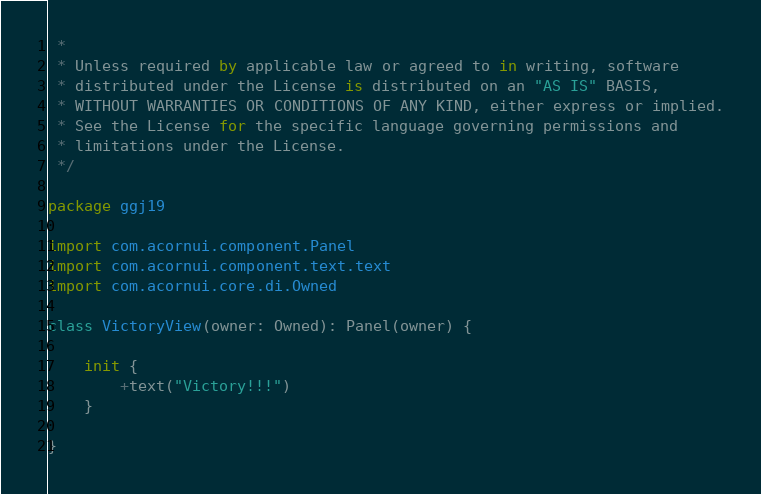<code> <loc_0><loc_0><loc_500><loc_500><_Kotlin_> *
 * Unless required by applicable law or agreed to in writing, software
 * distributed under the License is distributed on an "AS IS" BASIS,
 * WITHOUT WARRANTIES OR CONDITIONS OF ANY KIND, either express or implied.
 * See the License for the specific language governing permissions and
 * limitations under the License.
 */

package ggj19

import com.acornui.component.Panel
import com.acornui.component.text.text
import com.acornui.core.di.Owned

class VictoryView(owner: Owned): Panel(owner) {

	init {
		+text("Victory!!!")
	}

}
</code> 